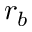<formula> <loc_0><loc_0><loc_500><loc_500>r _ { b }</formula> 